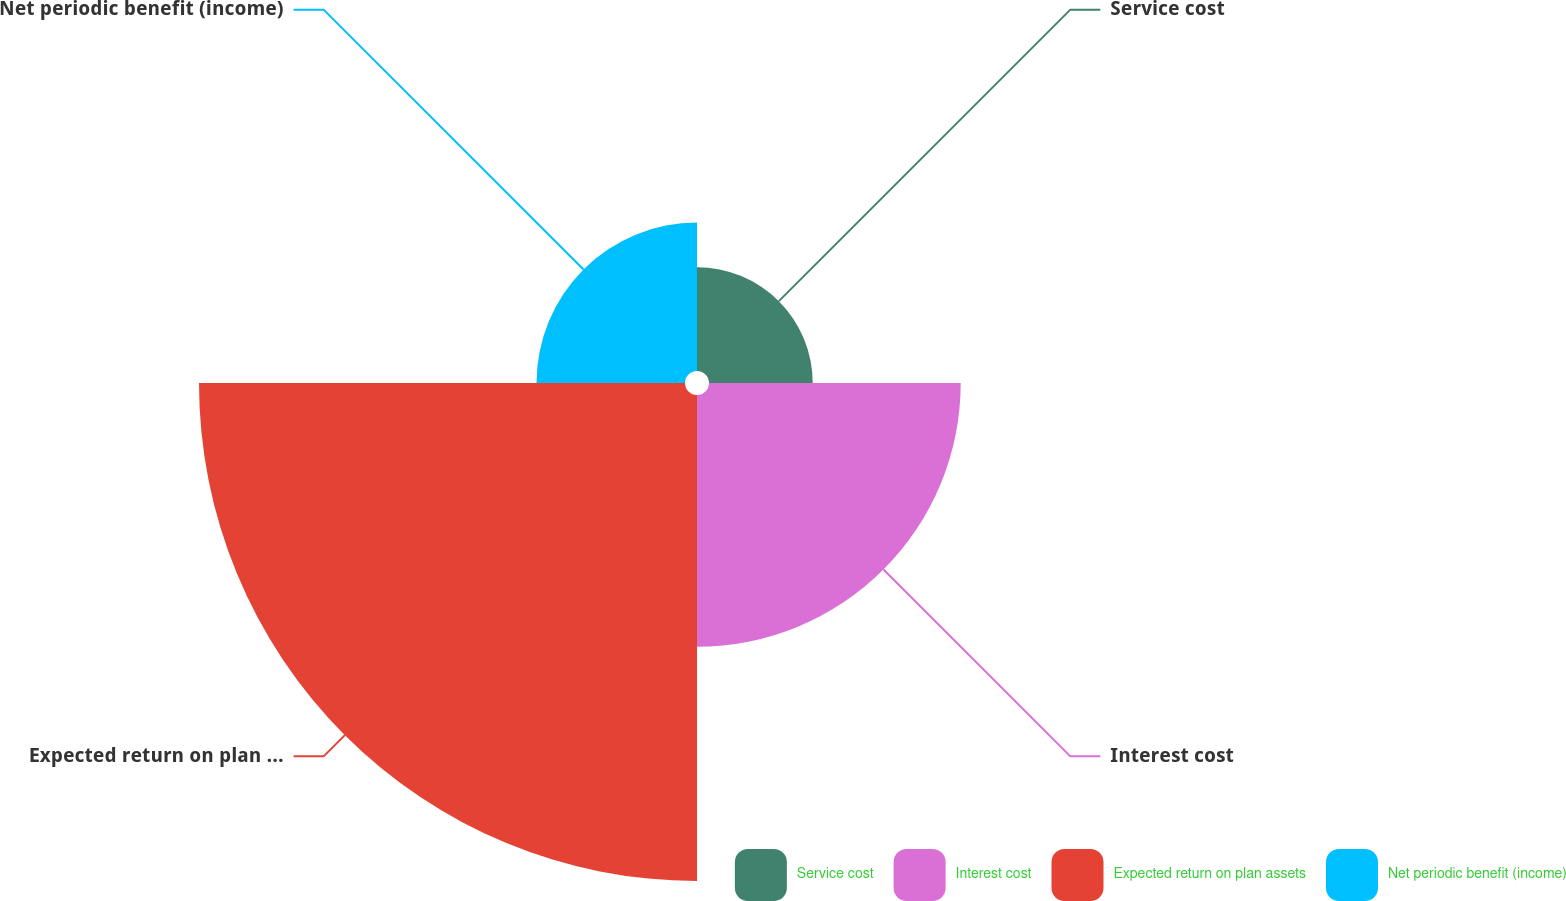Convert chart to OTSL. <chart><loc_0><loc_0><loc_500><loc_500><pie_chart><fcel>Service cost<fcel>Interest cost<fcel>Expected return on plan assets<fcel>Net periodic benefit (income)<nl><fcel>10.48%<fcel>25.43%<fcel>49.1%<fcel>15.0%<nl></chart> 